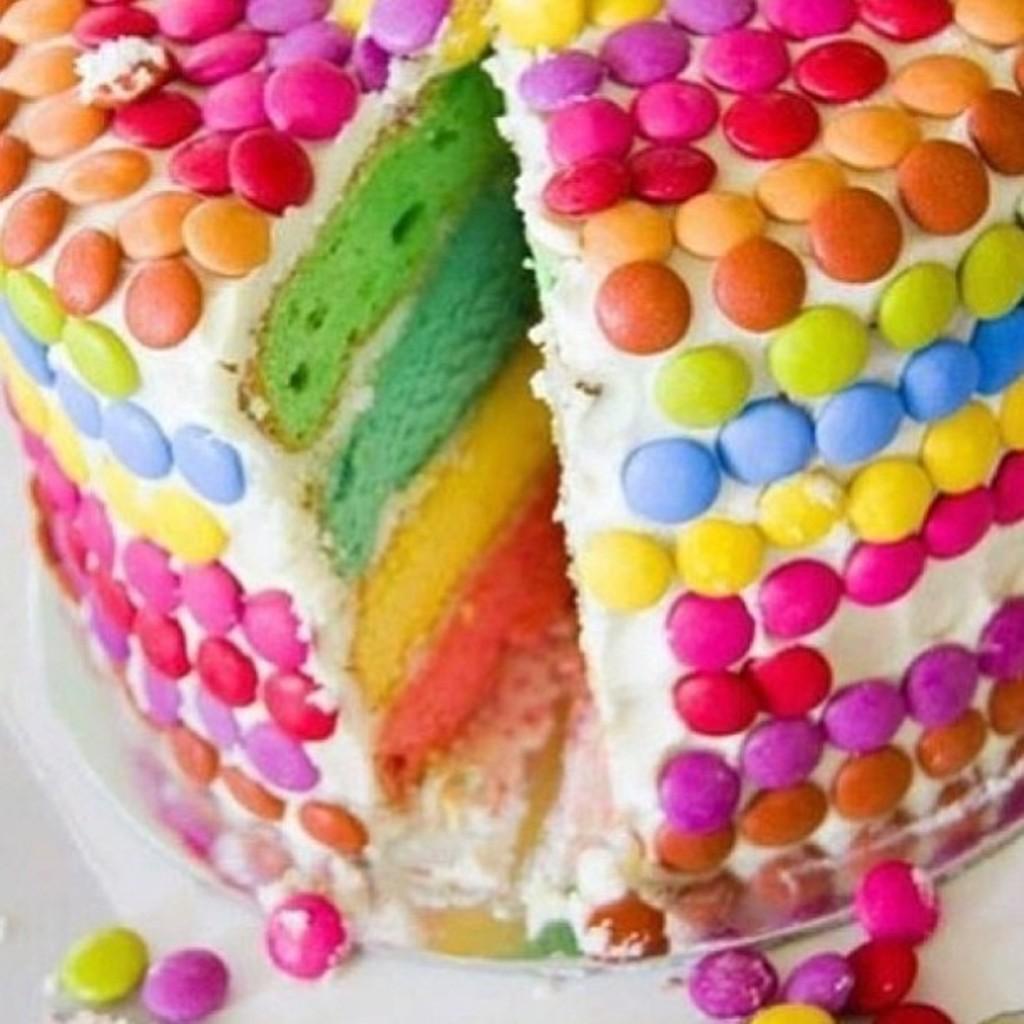Please provide a concise description of this image. In this picture i can see many gems on the cake. This cake is kept on the plate and plate is kept on the table. 